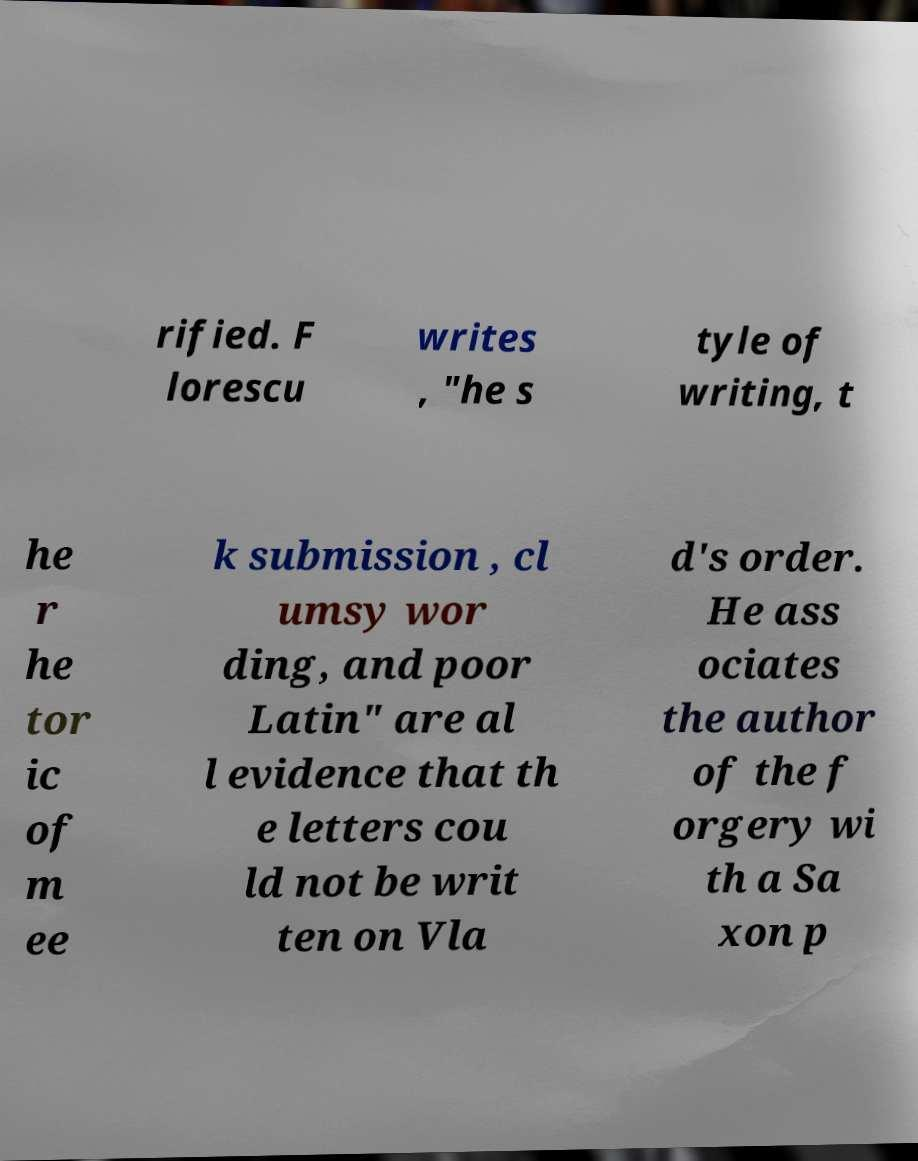Can you accurately transcribe the text from the provided image for me? rified. F lorescu writes , "he s tyle of writing, t he r he tor ic of m ee k submission , cl umsy wor ding, and poor Latin" are al l evidence that th e letters cou ld not be writ ten on Vla d's order. He ass ociates the author of the f orgery wi th a Sa xon p 